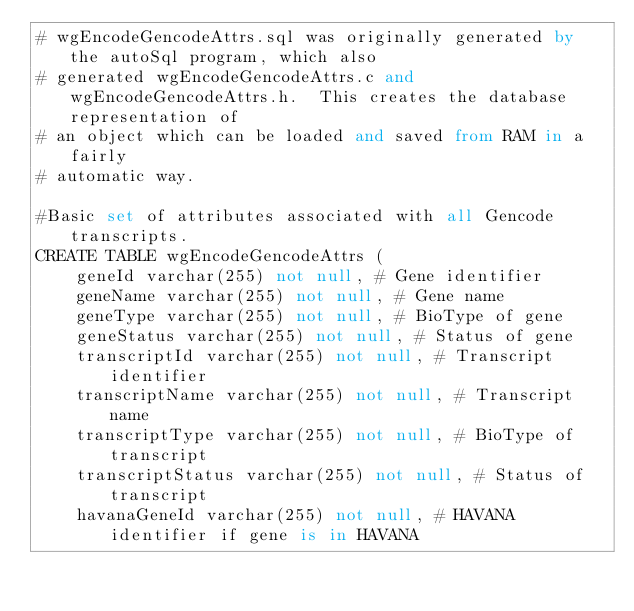<code> <loc_0><loc_0><loc_500><loc_500><_SQL_># wgEncodeGencodeAttrs.sql was originally generated by the autoSql program, which also 
# generated wgEncodeGencodeAttrs.c and wgEncodeGencodeAttrs.h.  This creates the database representation of
# an object which can be loaded and saved from RAM in a fairly 
# automatic way.

#Basic set of attributes associated with all Gencode transcripts.
CREATE TABLE wgEncodeGencodeAttrs (
    geneId varchar(255) not null,	# Gene identifier
    geneName varchar(255) not null,	# Gene name
    geneType varchar(255) not null,	# BioType of gene
    geneStatus varchar(255) not null,	# Status of gene
    transcriptId varchar(255) not null,	# Transcript identifier
    transcriptName varchar(255) not null,	# Transcript name
    transcriptType varchar(255) not null,	# BioType of transcript
    transcriptStatus varchar(255) not null,	# Status of transcript
    havanaGeneId varchar(255) not null,	# HAVANA identifier if gene is in HAVANA</code> 